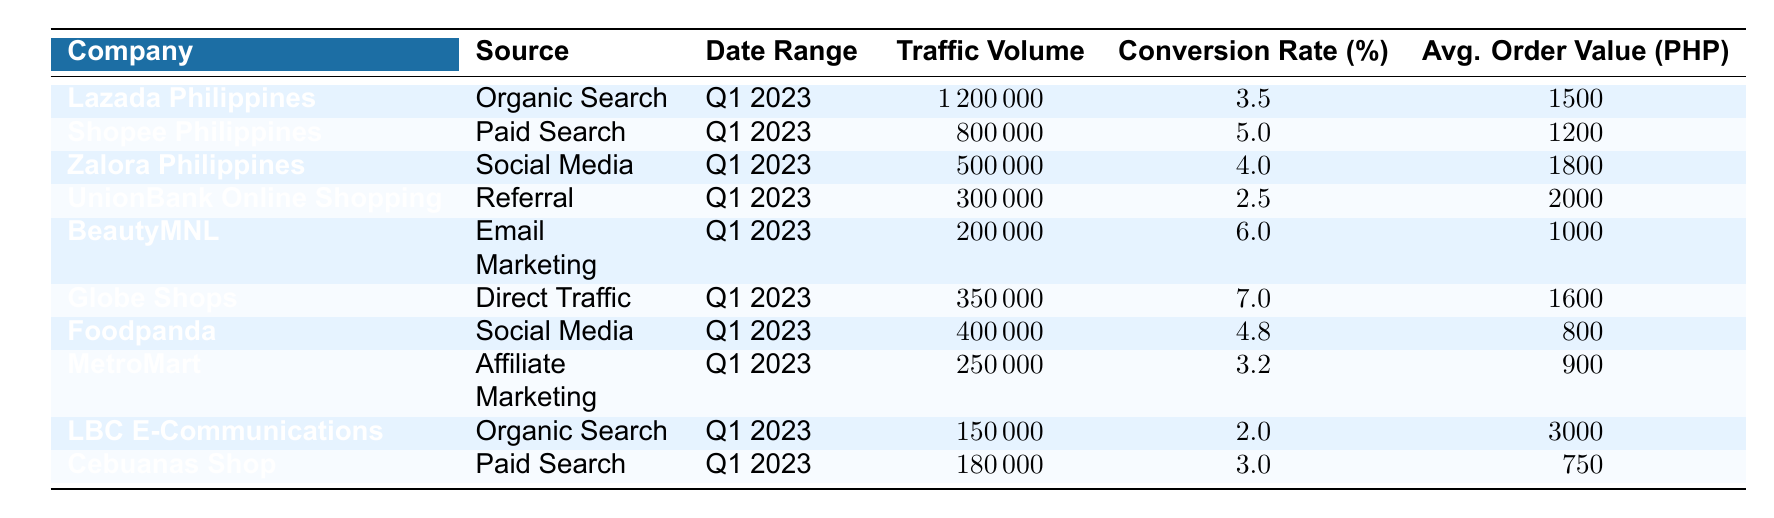What is the traffic volume for Lazada Philippines from Organic Search? Refer to the table and look under the "Traffic Volume" column for "Lazada Philippines" and "Organic Search." The value is 1,200,000.
Answer: 1,200,000 Which company's traffic source had the highest conversion rate? Check the "Conversion Rate" column for each company and identify the highest value. Globe Shops has the highest at 7.0%.
Answer: Globe Shops What is the average order value for BeautyMNL? Locate the "Avg. Order Value" column for "BeautyMNL" and read the corresponding value, which is 1,000 PHP.
Answer: 1,000 PHP What is the difference in traffic volume between Shopee Philippines and Cebuanas Shop? Look at the "Traffic Volume" values for both. Shopee Philippines has 800,000, and Cebuanas Shop has 180,000, so the difference is 800,000 - 180,000 = 620,000.
Answer: 620,000 Which two companies had Social Media as their traffic source? Inspect the "Source" column and find companies that list "Social Media." The companies are Zalora Philippines and Foodpanda.
Answer: Zalora Philippines and Foodpanda What is the total traffic volume for companies using Organic Search? Identify all companies with "Organic Search" in the "Source" column: Lazada Philippines (1,200,000) and LBC E-Communications (150,000). The total is 1,200,000 + 150,000 = 1,350,000.
Answer: 1,350,000 Is the average order value higher for direct traffic or referral traffic? Compare the "Avg. Order Value" for Globe Shops (Direct Traffic: 1,600 PHP) and UnionBank Online Shopping (Referral: 2,000 PHP). Referral traffic has a higher value: 2,000 PHP.
Answer: Yes What percentage of the traffic from Email Marketing converted into sales? Check the "Conversion Rate" for BeautyMNL under the Email Marketing source, which is 6.0%.
Answer: 6.0% What is the average traffic volume of the companies listed? Sum all the "Traffic Volume" values (1,200,000 + 800,000 + 500,000 + 300,000 + 200,000 + 350,000 + 400,000 + 250,000 + 150,000 + 180,000 = 4,930,000) and divide by the number of companies (10). The average is 4,930,000 / 10 = 493,000.
Answer: 493,000 Which company had the lowest traffic volume and what was it? Review the "Traffic Volume" column to find the smallest value, which is 150,000 for LBC E-Communications.
Answer: LBC E-Communications: 150,000 